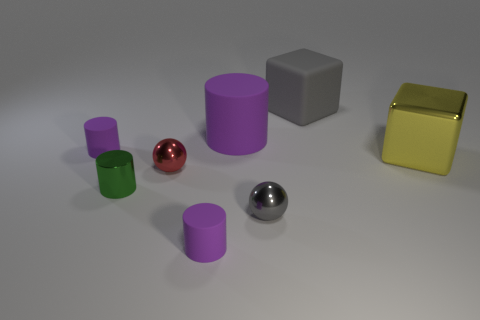What number of objects are either gray spheres that are on the right side of the red metal ball or yellow things?
Make the answer very short. 2. What is the material of the large object that is in front of the cylinder that is behind the matte object on the left side of the green metal cylinder?
Your answer should be compact. Metal. Are there more tiny purple things on the right side of the green metal cylinder than large purple matte things that are on the right side of the big shiny cube?
Provide a succinct answer. Yes. What number of cylinders are either tiny green things or tiny purple objects?
Offer a terse response. 3. There is a big rubber thing that is right of the gray object in front of the large rubber cylinder; what number of big shiny things are behind it?
Your answer should be compact. 0. What is the material of the object that is the same color as the large rubber cube?
Your response must be concise. Metal. Is the number of big matte cylinders greater than the number of large purple matte blocks?
Your answer should be compact. Yes. Do the gray ball and the green object have the same size?
Offer a very short reply. Yes. What number of objects are yellow objects or small red shiny objects?
Keep it short and to the point. 2. There is a small purple thing right of the small purple rubber cylinder that is to the left of the small rubber thing that is in front of the red ball; what shape is it?
Offer a terse response. Cylinder. 